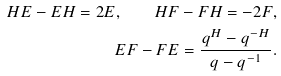<formula> <loc_0><loc_0><loc_500><loc_500>H E - E H = 2 E , \quad H F - F H = - 2 F , \\ E F - F E = \frac { q ^ { H } - q ^ { - H } } { q - q ^ { - 1 } } .</formula> 